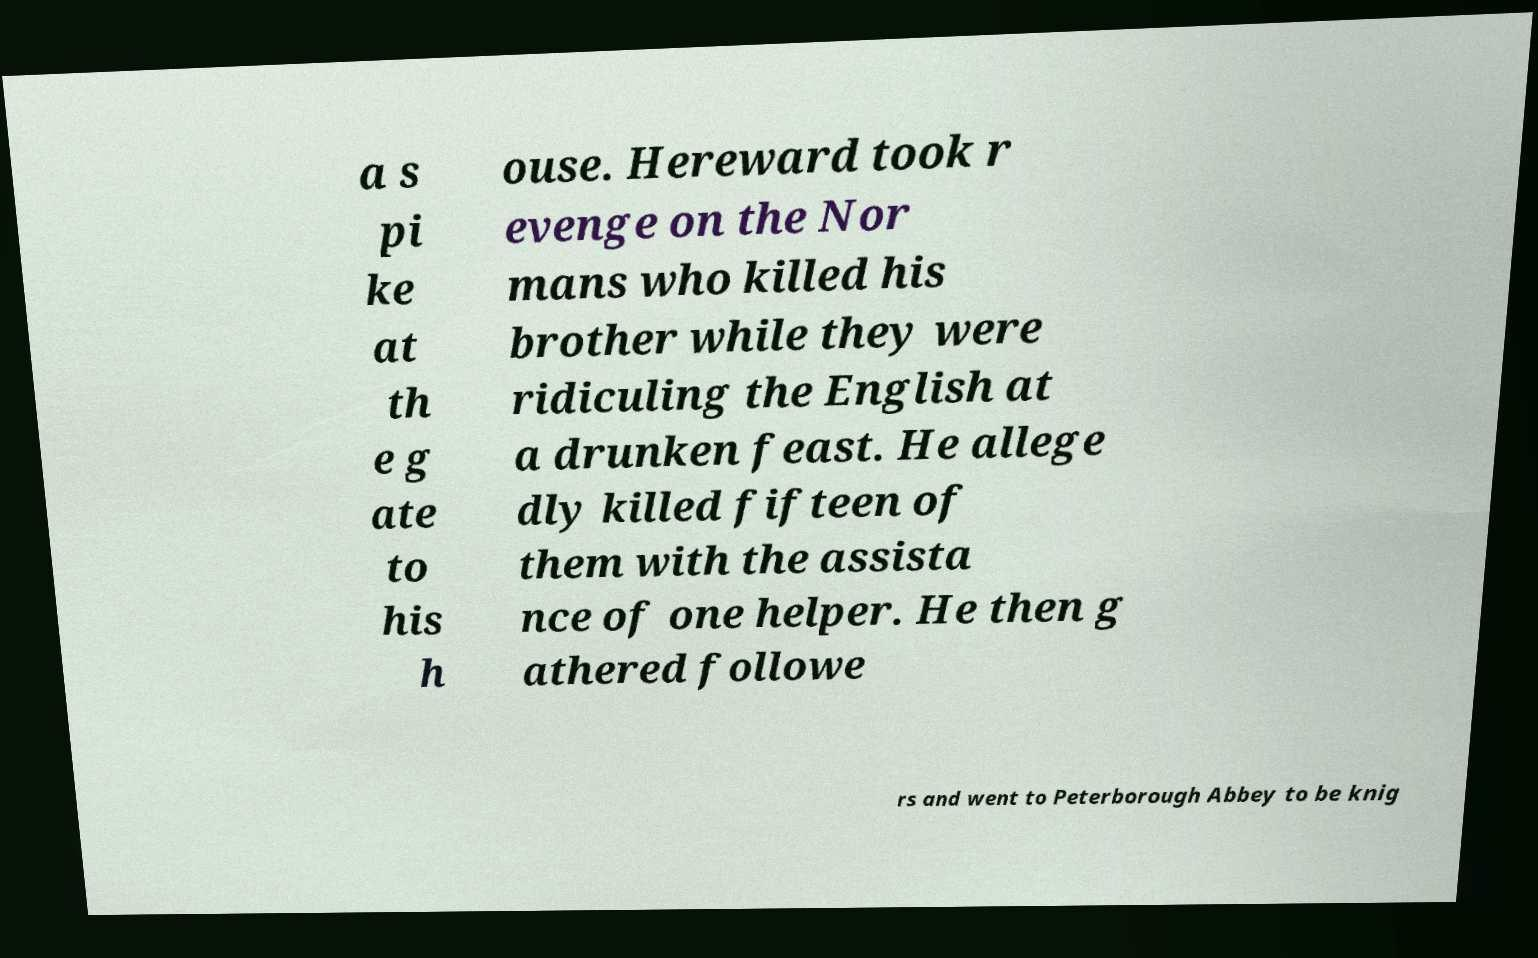Please read and relay the text visible in this image. What does it say? a s pi ke at th e g ate to his h ouse. Hereward took r evenge on the Nor mans who killed his brother while they were ridiculing the English at a drunken feast. He allege dly killed fifteen of them with the assista nce of one helper. He then g athered followe rs and went to Peterborough Abbey to be knig 